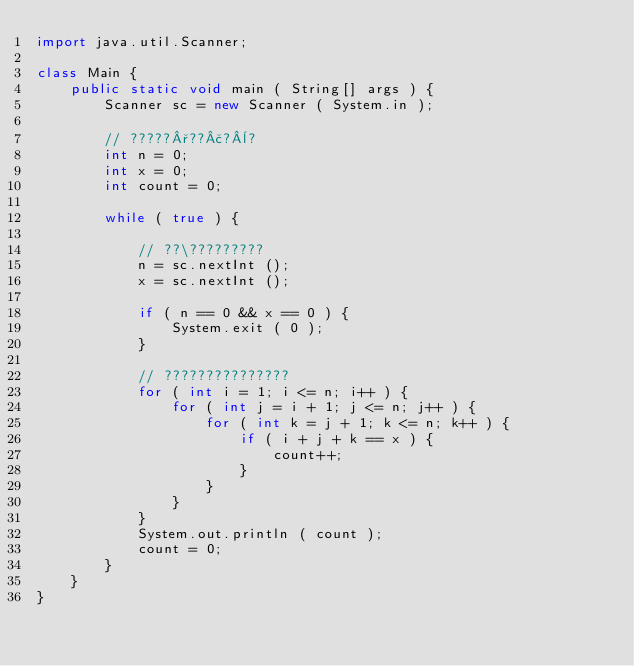<code> <loc_0><loc_0><loc_500><loc_500><_Java_>import java.util.Scanner;

class Main {
	public static void main ( String[] args ) {
		Scanner sc = new Scanner ( System.in );

		// ?????°??£?¨?
		int n = 0;
		int x = 0;
		int count = 0;

		while ( true ) {
			
			// ??\?????????
			n = sc.nextInt ();
			x = sc.nextInt ();

			if ( n == 0 && x == 0 ) {
				System.exit ( 0 );
			}

			// ???????????????
			for ( int i = 1; i <= n; i++ ) {
				for ( int j = i + 1; j <= n; j++ ) {
					for ( int k = j + 1; k <= n; k++ ) {
						if ( i + j + k == x ) {
							count++;
						}
					}
				}
			}
			System.out.println ( count );
			count = 0;
		}
	}
}</code> 